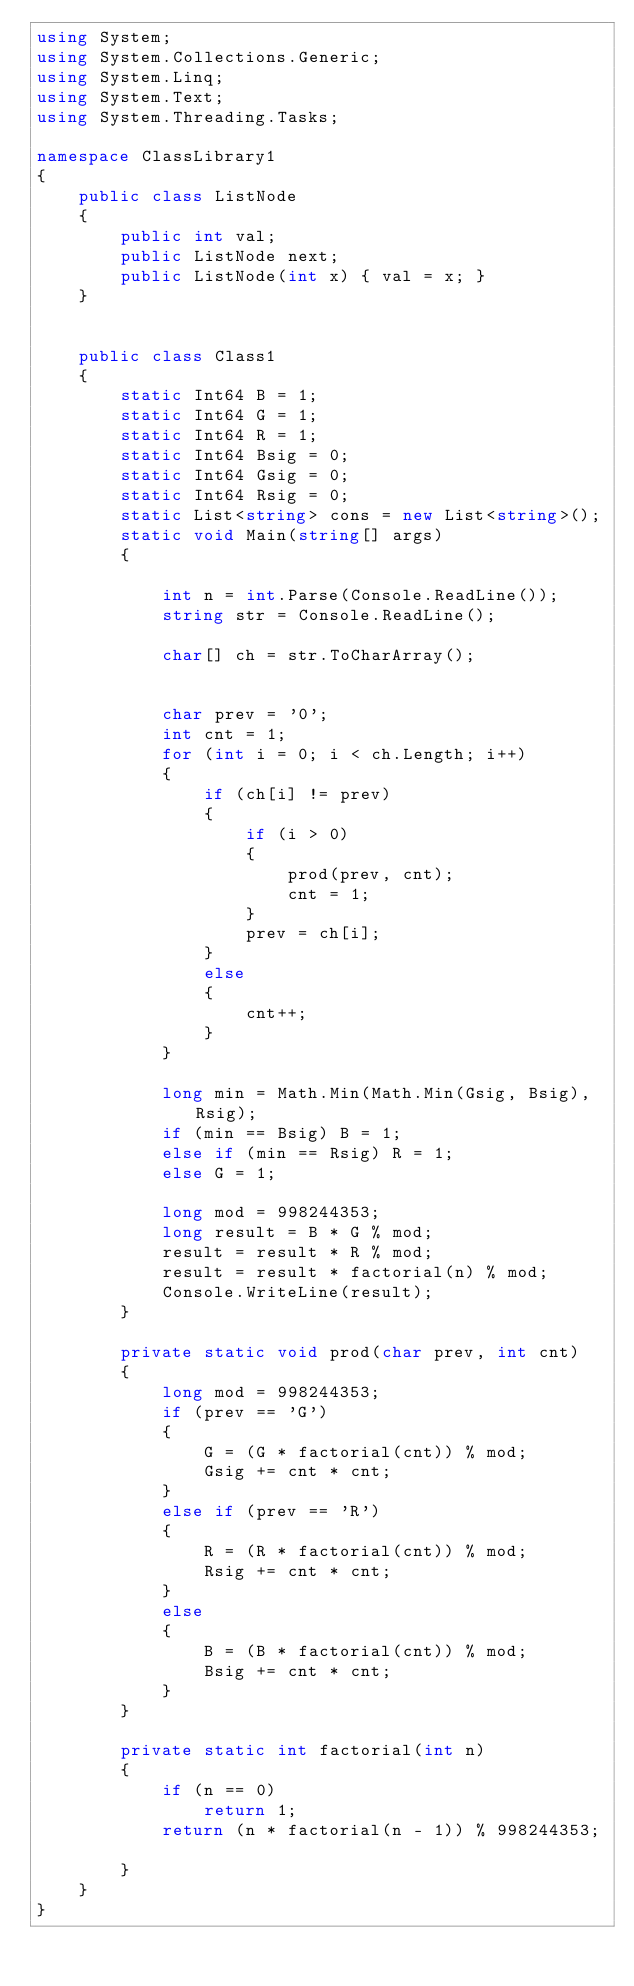Convert code to text. <code><loc_0><loc_0><loc_500><loc_500><_C#_>using System;
using System.Collections.Generic;
using System.Linq;
using System.Text;
using System.Threading.Tasks;

namespace ClassLibrary1
{
    public class ListNode
    {
        public int val;
        public ListNode next;
        public ListNode(int x) { val = x; }
    }


    public class Class1
    {
        static Int64 B = 1;
        static Int64 G = 1;
        static Int64 R = 1;
        static Int64 Bsig = 0;
        static Int64 Gsig = 0;
        static Int64 Rsig = 0;
        static List<string> cons = new List<string>();
        static void Main(string[] args)
        {

            int n = int.Parse(Console.ReadLine());
            string str = Console.ReadLine();

            char[] ch = str.ToCharArray();


            char prev = '0';
            int cnt = 1;
            for (int i = 0; i < ch.Length; i++)
            {
                if (ch[i] != prev)
                {
                    if (i > 0)
                    {
                        prod(prev, cnt);
                        cnt = 1;
                    }
                    prev = ch[i];
                }
                else
                {
                    cnt++;
                }
            }

            long min = Math.Min(Math.Min(Gsig, Bsig), Rsig);
            if (min == Bsig) B = 1;
            else if (min == Rsig) R = 1;
            else G = 1;

            long mod = 998244353;
            long result = B * G % mod;
            result = result * R % mod;
            result = result * factorial(n) % mod;
            Console.WriteLine(result);
        }

        private static void prod(char prev, int cnt)
        {
            long mod = 998244353;
            if (prev == 'G')
            {
                G = (G * factorial(cnt)) % mod;
                Gsig += cnt * cnt;
            }
            else if (prev == 'R')
            {
                R = (R * factorial(cnt)) % mod;
                Rsig += cnt * cnt;
            }
            else
            {
                B = (B * factorial(cnt)) % mod;
                Bsig += cnt * cnt;
            }
        }

        private static int factorial(int n)
        {
            if (n == 0)
                return 1;
            return (n * factorial(n - 1)) % 998244353;

        }
    }
}</code> 